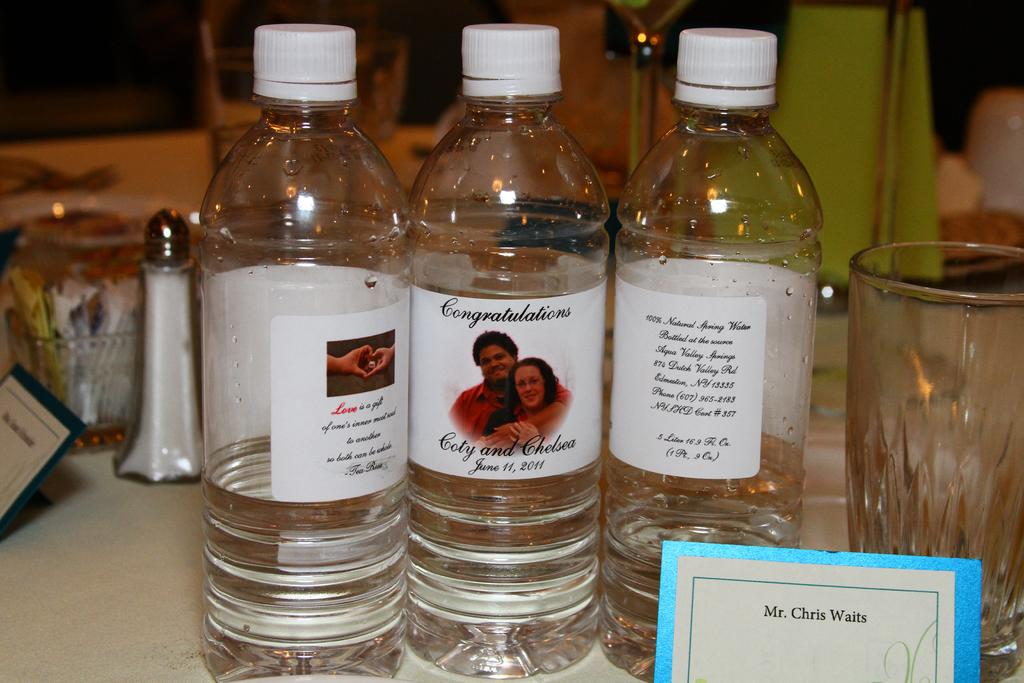Provide a one-sentence caption for the provided image. Personalized bottles of water congratulate Coty and Chelsea on their wedding. 